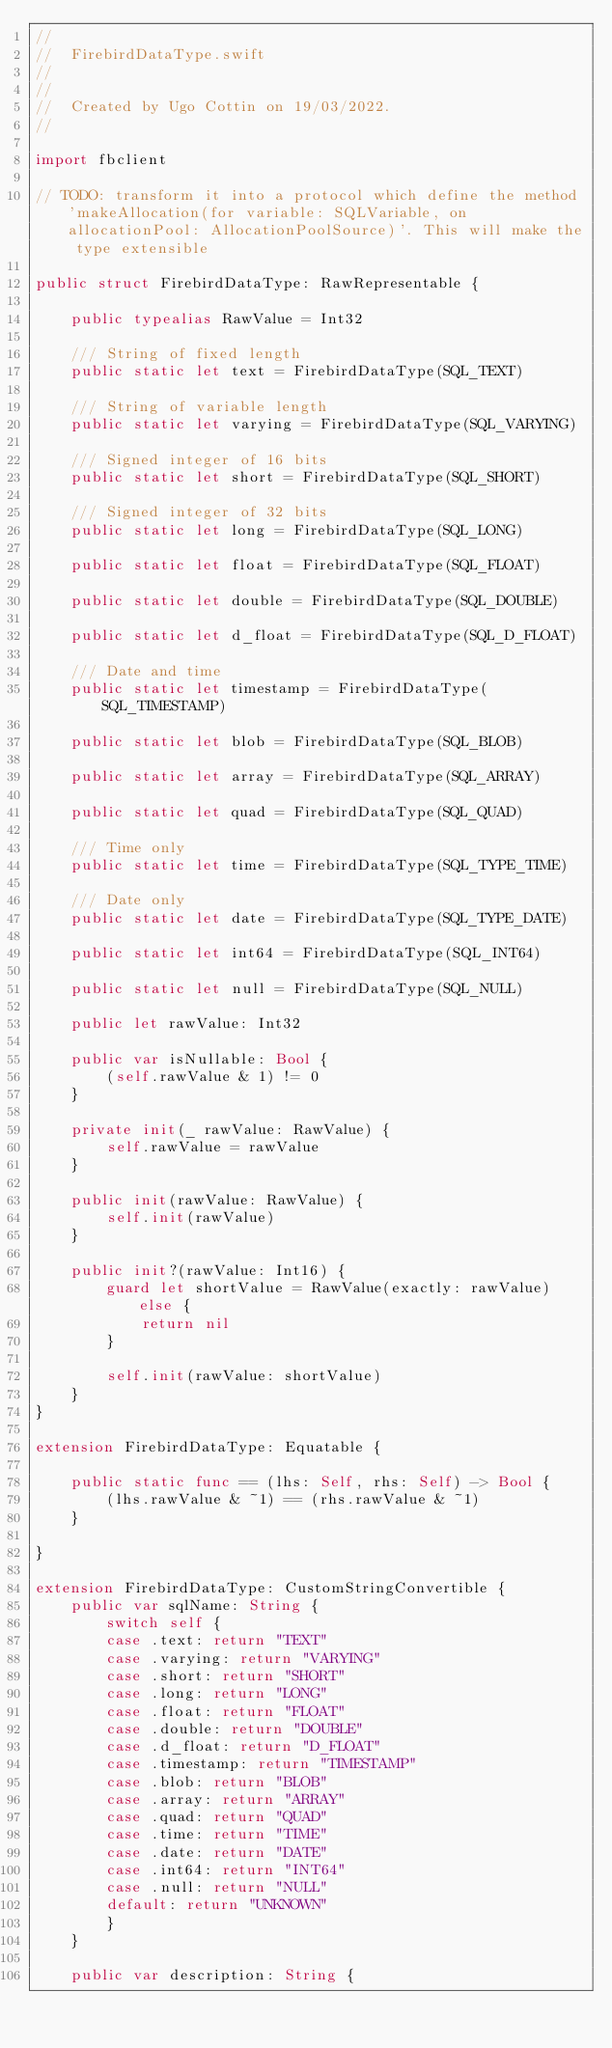Convert code to text. <code><loc_0><loc_0><loc_500><loc_500><_Swift_>//
//  FirebirdDataType.swift
//  
//
//  Created by Ugo Cottin on 19/03/2022.
//

import fbclient

// TODO: transform it into a protocol which define the method 'makeAllocation(for variable: SQLVariable, on allocationPool: AllocationPoolSource)'. This will make the type extensible

public struct FirebirdDataType: RawRepresentable {
	
	public typealias RawValue = Int32
	
	/// String of fixed length
	public static let text = FirebirdDataType(SQL_TEXT)
	
	/// String of variable length
	public static let varying = FirebirdDataType(SQL_VARYING)
	
	/// Signed integer of 16 bits
	public static let short = FirebirdDataType(SQL_SHORT)
	
	/// Signed integer of 32 bits
	public static let long = FirebirdDataType(SQL_LONG)
	
	public static let float = FirebirdDataType(SQL_FLOAT)
	
	public static let double = FirebirdDataType(SQL_DOUBLE)
	
	public static let d_float = FirebirdDataType(SQL_D_FLOAT)
	
	/// Date and time
	public static let timestamp = FirebirdDataType(SQL_TIMESTAMP)
	
	public static let blob = FirebirdDataType(SQL_BLOB)
	
	public static let array = FirebirdDataType(SQL_ARRAY)
	
	public static let quad = FirebirdDataType(SQL_QUAD)
	
	/// Time only
	public static let time = FirebirdDataType(SQL_TYPE_TIME)
	
	/// Date only
	public static let date = FirebirdDataType(SQL_TYPE_DATE)
	
	public static let int64 = FirebirdDataType(SQL_INT64)
	
	public static let null = FirebirdDataType(SQL_NULL)
	
	public let rawValue: Int32
	
	public var isNullable: Bool {
		(self.rawValue & 1) != 0
	}
	
	private init(_ rawValue: RawValue) {
		self.rawValue = rawValue
	}
	
	public init(rawValue: RawValue) {
		self.init(rawValue)
	}
	
	public init?(rawValue: Int16) {
		guard let shortValue = RawValue(exactly: rawValue) else {
			return nil
		}
		
		self.init(rawValue: shortValue)
	}
}

extension FirebirdDataType: Equatable {
	
	public static func == (lhs: Self, rhs: Self) -> Bool {
		(lhs.rawValue & ~1) == (rhs.rawValue & ~1)
	}
	
}

extension FirebirdDataType: CustomStringConvertible {
	public var sqlName: String {
		switch self {
		case .text: return "TEXT"
		case .varying: return "VARYING"
		case .short: return "SHORT"
		case .long: return "LONG"
		case .float: return "FLOAT"
		case .double: return "DOUBLE"
		case .d_float: return "D_FLOAT"
		case .timestamp: return "TIMESTAMP"
		case .blob: return "BLOB"
		case .array: return "ARRAY"
		case .quad: return "QUAD"
		case .time: return "TIME"
		case .date: return "DATE"
		case .int64: return "INT64"
		case .null: return "NULL"
		default: return "UNKNOWN"
		}
	}
	
	public var description: String {</code> 